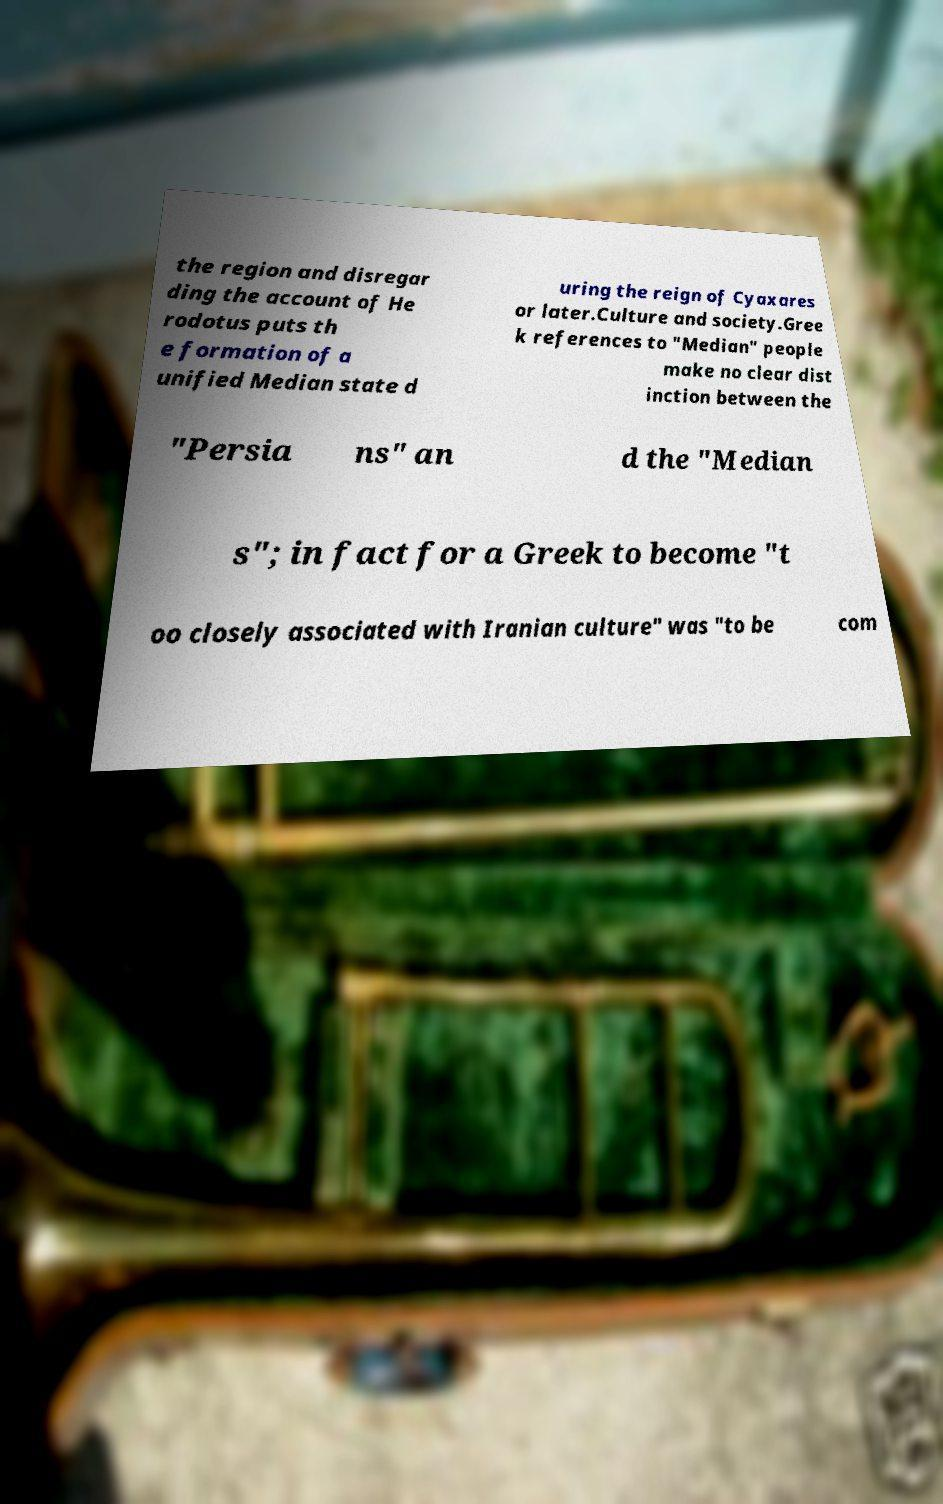What messages or text are displayed in this image? I need them in a readable, typed format. the region and disregar ding the account of He rodotus puts th e formation of a unified Median state d uring the reign of Cyaxares or later.Culture and society.Gree k references to "Median" people make no clear dist inction between the "Persia ns" an d the "Median s"; in fact for a Greek to become "t oo closely associated with Iranian culture" was "to be com 